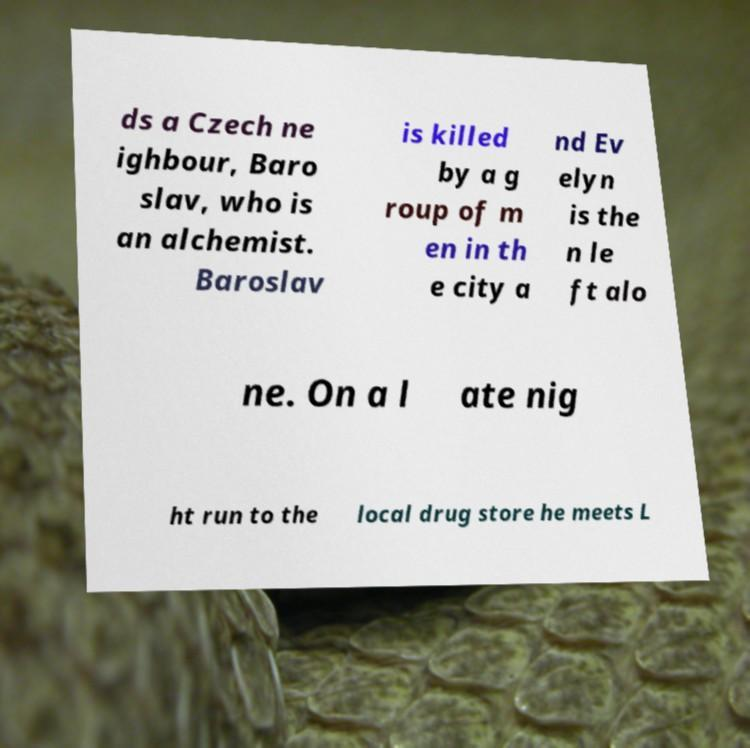Can you read and provide the text displayed in the image?This photo seems to have some interesting text. Can you extract and type it out for me? ds a Czech ne ighbour, Baro slav, who is an alchemist. Baroslav is killed by a g roup of m en in th e city a nd Ev elyn is the n le ft alo ne. On a l ate nig ht run to the local drug store he meets L 